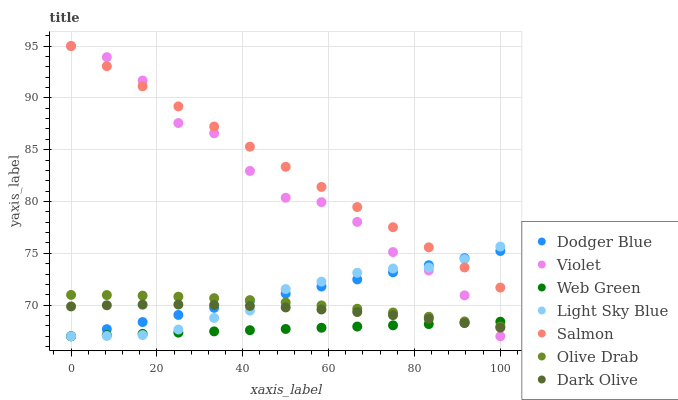Does Web Green have the minimum area under the curve?
Answer yes or no. Yes. Does Salmon have the maximum area under the curve?
Answer yes or no. Yes. Does Salmon have the minimum area under the curve?
Answer yes or no. No. Does Web Green have the maximum area under the curve?
Answer yes or no. No. Is Dodger Blue the smoothest?
Answer yes or no. Yes. Is Violet the roughest?
Answer yes or no. Yes. Is Salmon the smoothest?
Answer yes or no. No. Is Salmon the roughest?
Answer yes or no. No. Does Web Green have the lowest value?
Answer yes or no. Yes. Does Salmon have the lowest value?
Answer yes or no. No. Does Salmon have the highest value?
Answer yes or no. Yes. Does Web Green have the highest value?
Answer yes or no. No. Is Olive Drab less than Salmon?
Answer yes or no. Yes. Is Salmon greater than Dark Olive?
Answer yes or no. Yes. Does Violet intersect Dark Olive?
Answer yes or no. Yes. Is Violet less than Dark Olive?
Answer yes or no. No. Is Violet greater than Dark Olive?
Answer yes or no. No. Does Olive Drab intersect Salmon?
Answer yes or no. No. 